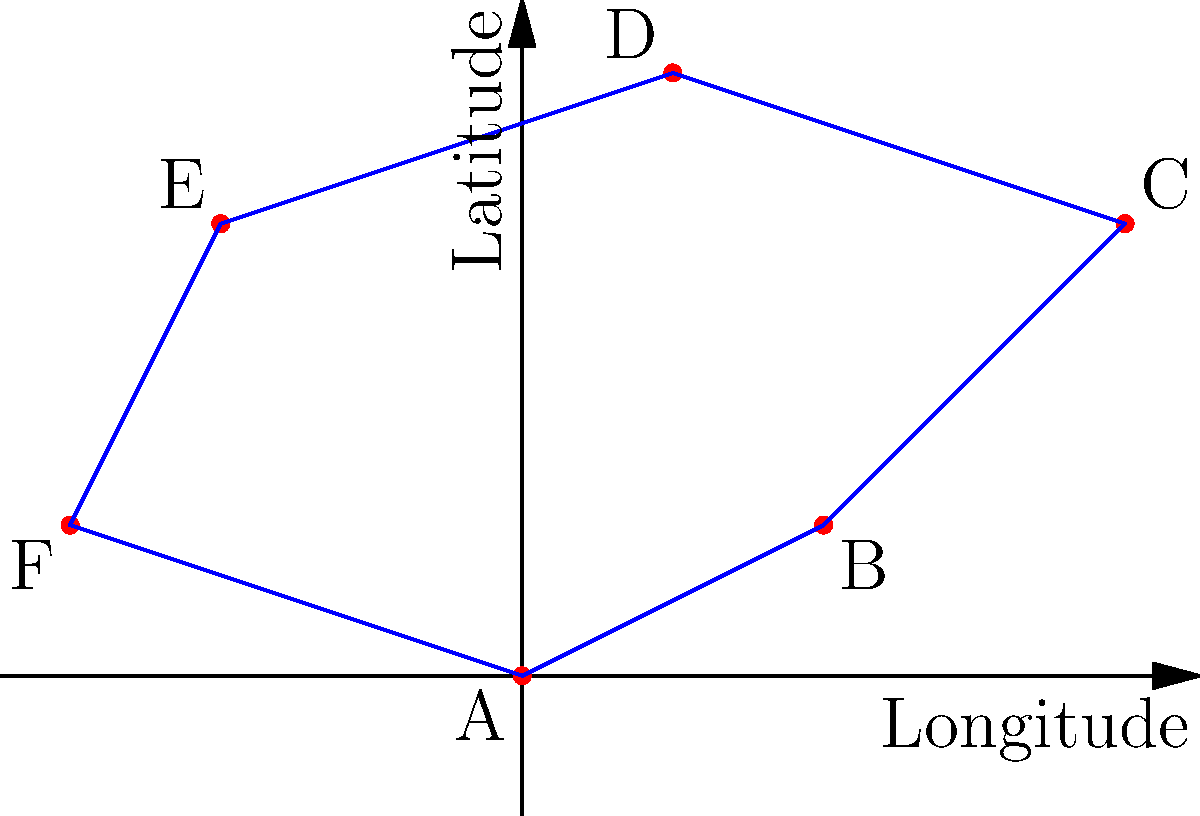As part of your role in monitoring invasive species, you've received reports of an aggressive non-native plant spreading in a forested area. The coordinates of confirmed sightings are plotted on the map above. What is the approximate area (in square degrees) of the affected region, assuming the invasive species has spread to fill the entire polygon formed by connecting these points? To solve this problem, we need to follow these steps:

1) Identify the polygon: The affected area forms an irregular hexagon with vertices A(0,0), B(2,1), C(4,3), D(1,4), E(-2,3), and F(-3,1).

2) Split the hexagon into triangles: We can divide this hexagon into four triangles: ABC, ACD, ADE, and AEF.

3) Calculate the area of each triangle using the formula:
   Area = $\frac{1}{2}|x_1(y_2 - y_3) + x_2(y_3 - y_1) + x_3(y_1 - y_2)|$

   For triangle ABC:
   Area_ABC = $\frac{1}{2}|0(1 - 3) + 2(3 - 0) + 4(0 - 1)| = 3$

   For triangle ACD:
   Area_ACD = $\frac{1}{2}|0(4 - 3) + 1(3 - 0) + 4(0 - 4)| = 7$

   For triangle ADE:
   Area_ADE = $\frac{1}{2}|0(3 - 4) + (-2)(4 - 0) + 1(0 - 3)| = 5.5$

   For triangle AEF:
   Area_AEF = $\frac{1}{2}|0(1 - 3) + (-3)(3 - 0) + (-2)(0 - 1)| = 4.5$

4) Sum up all the areas:
   Total Area = 3 + 7 + 5.5 + 4.5 = 20 square degrees

Therefore, the approximate area of the affected region is 20 square degrees.
Answer: 20 square degrees 